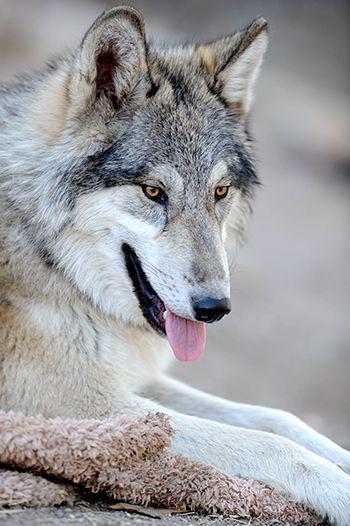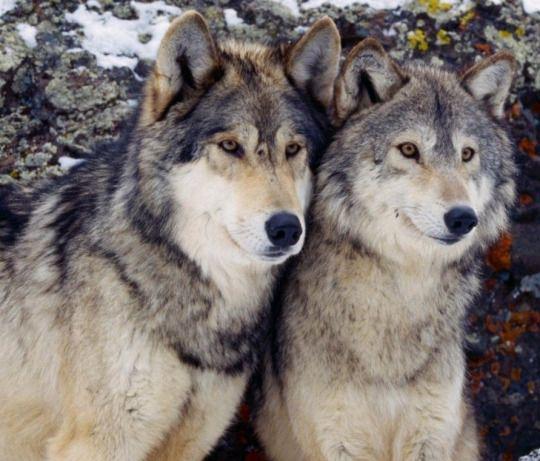The first image is the image on the left, the second image is the image on the right. Assess this claim about the two images: "wolves are facing oposite directions in the image pair". Correct or not? Answer yes or no. No. 